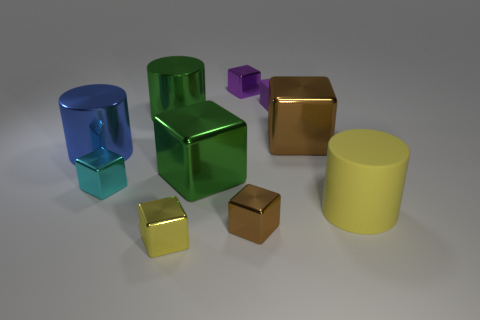Subtract all big yellow rubber cylinders. How many cylinders are left? 2 Subtract all brown blocks. How many blocks are left? 5 Subtract all cubes. How many objects are left? 3 Subtract 2 cylinders. How many cylinders are left? 1 Subtract all blue cylinders. Subtract all gray balls. How many cylinders are left? 2 Subtract all brown cylinders. How many brown blocks are left? 2 Subtract all small cyan objects. Subtract all yellow cylinders. How many objects are left? 8 Add 9 matte cylinders. How many matte cylinders are left? 10 Add 7 cyan metal blocks. How many cyan metal blocks exist? 8 Subtract 1 green blocks. How many objects are left? 9 